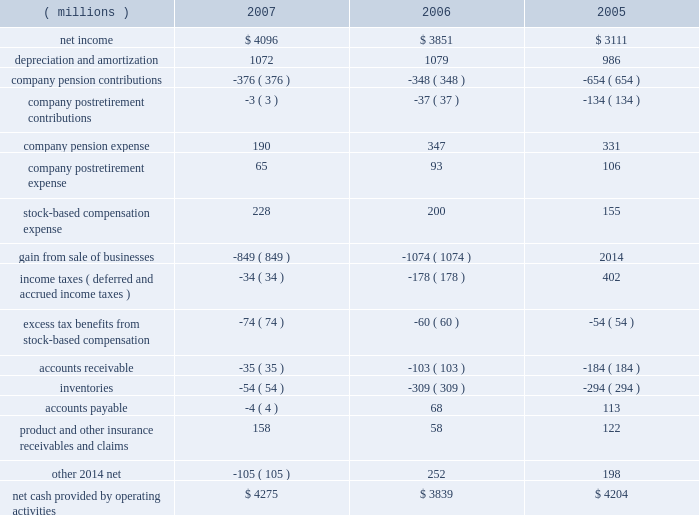3m 2019s cash and cash equivalents balance at december 31 , 2007 totaled $ 1.896 billion , with an additional $ 1.059 billion in current and long-term marketable securities .
3m 2019s strong balance sheet and liquidity provide the company with significant flexibility to take advantage of numerous opportunities going forward .
The company will continue to invest in its operations to drive growth , including continual review of acquisition opportunities .
As previously discussed , 3m expects to complete the acquisition of aearo holding corp .
For approximately $ 1.2 billion in 2008 .
3m paid dividends of $ 1.380 billion in 2007 , and has a long history of dividend increases .
In february 2008 , the board of directors increased the quarterly dividend on 3m common stock by 4.2% ( 4.2 % ) to 50 cents per share , equivalent to an annual dividend of $ 2.00 per share .
In february 2007 , 3m 2019s board of directors authorized a two-year share repurchase of up to $ 7.0 billion for the period from february 12 , 2007 to february 28 , 2009 .
At december 31 , 2007 , the company has $ 4.1 billion remaining under this authorization , which the company does not currently expect to fully utilize by february 28 , 2009 .
In 2008 , the company expects to contribute an amount in the range of $ 100 million to $ 400 million to its u.s .
And international pension plans .
The company does not have a required minimum pension contribution obligation for its u.s .
Plans in 2008 .
Therefore , the amount of the anticipated discretionary contribution could vary significantly depending on the u.s.-plans funding status as of the 2008 measurement date and the anticipated tax deductibility of the contribution .
Future contributions will also depend on market conditions , interest rates and other factors .
3m believes its strong cash flow and balance sheet will allow it to fund future pension needs without compromising growth opportunities .
The company uses various working capital measures that place emphasis and focus on certain working capital assets and liabilities .
These measures are not defined under u.s .
Generally accepted accounting principles and may not be computed the same as similarly titled measures used by other companies .
One of the primary working capital measures 3m uses is a combined index , which includes accounts receivable , inventory and accounts payable .
This combined index ( defined as quarterly net sales 2013 fourth quarter at year-end 2013 multiplied by four , divided by ending net accounts receivable plus inventory less accounts payable ) was 5.3 at december 31 , 2007 , down from 5.4 at december 31 , 2006 .
Receivables increased $ 260 million , or 8.4% ( 8.4 % ) , compared with december 31 , 2006 .
Currency translation increased accounts receivable by $ 159 million year-on-year , as the u.s .
Dollar weakened in aggregate against a multitude of currencies .
Inventories increased $ 251 million , or 9.7% ( 9.7 % ) , compared with december 31 , 2006 .
Currency translation increased inventories by $ 132 million year-on-year .
Accounts payable increased $ 103 million compared with december 31 , 2006 , with $ 65 million of this year-on-year increase related to currency translation .
Cash flows from operating , investing and financing activities are provided in the tables that follow .
Individual amounts in the consolidated statement of cash flows exclude the effects of acquisitions , divestitures and exchange rate impacts , which are presented separately in the cash flows .
Thus , the amounts presented in the following operating , investing and financing activities tables reflect changes in balances from period to period adjusted for these effects .
Cash flows from operating activities : years ended december 31 .

What was the percentage change in the net income? 
Computations: ((4096 - 3851) / 3851)
Answer: 0.06362. 